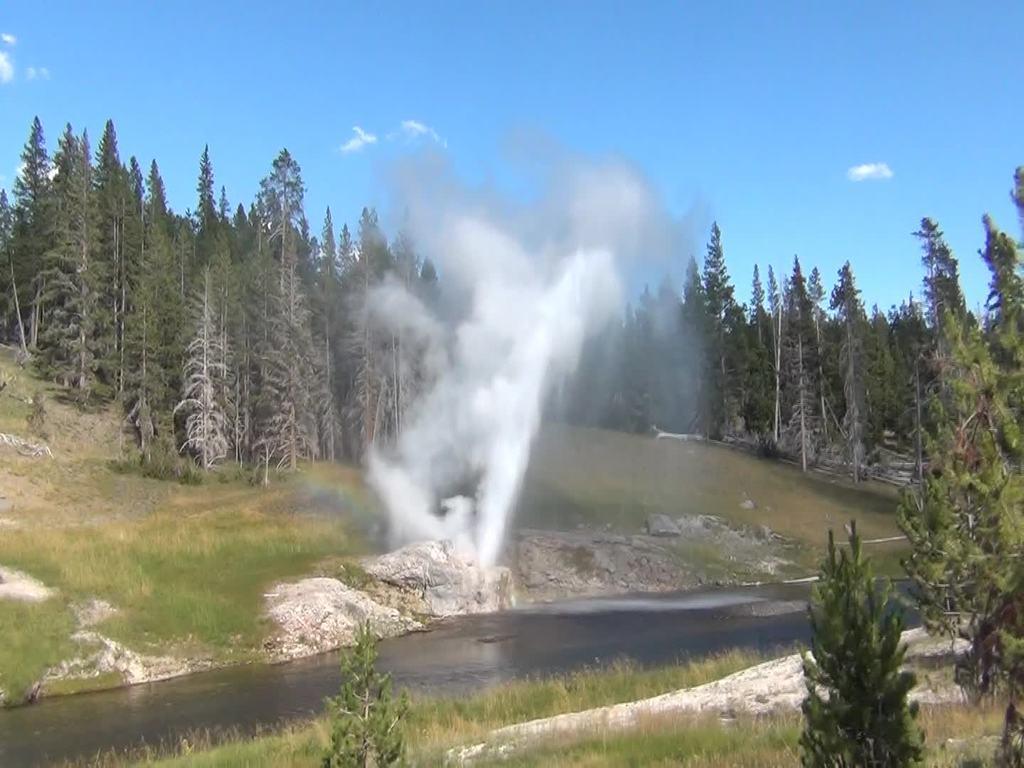Could you give a brief overview of what you see in this image? In this image I can see the water, some grass, few rocks and few trees and I can see the white colored smoke in the air. In the background I can see few trees and the sky. 